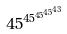<formula> <loc_0><loc_0><loc_500><loc_500>4 5 ^ { 4 5 ^ { 4 5 ^ { 4 5 ^ { 4 3 } } } }</formula> 